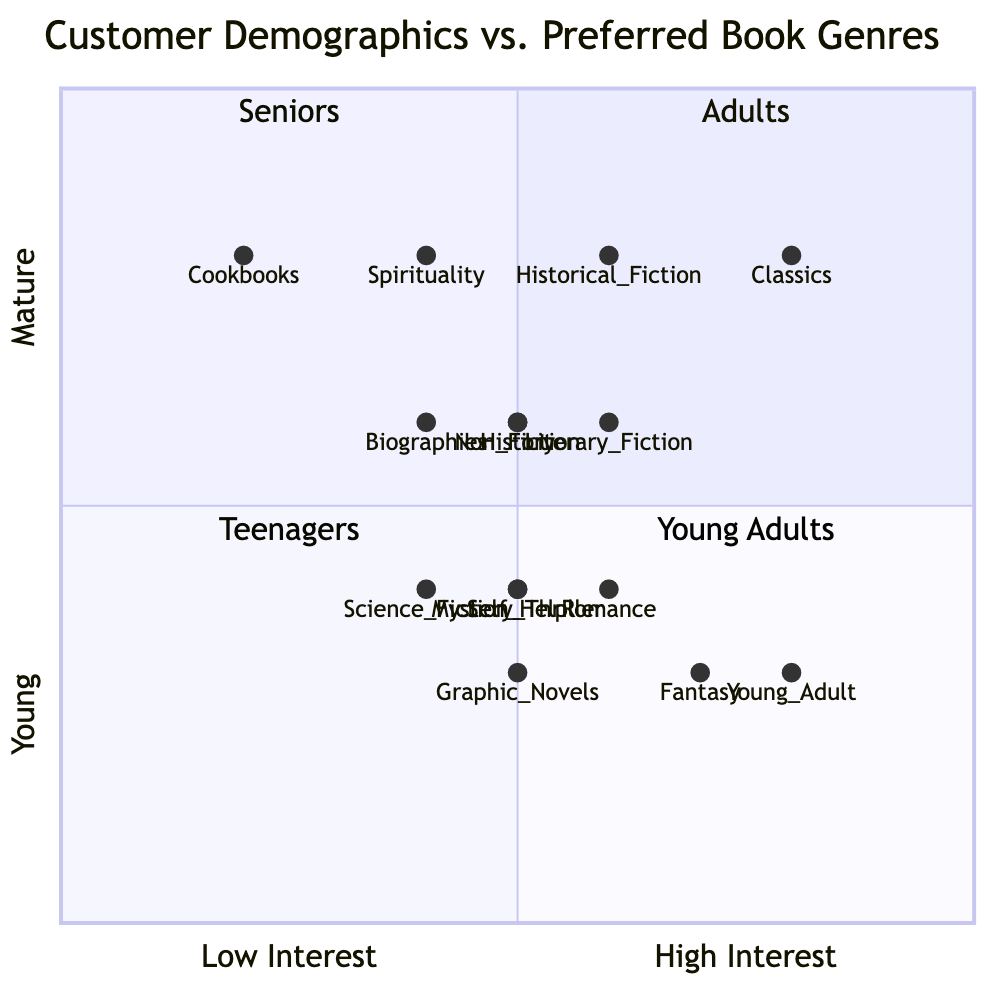What genre is most popular among teenagers? The diagram indicates that "Young Adult" with a value of 40 is the most popular genre in the Teenagers quadrant.
Answer: Young Adult Which demographic shows the highest interest in classics? According to the diagram, the "Seniors" demographic has the highest interest in "Classics," with a value of 40.
Answer: Seniors How many genres are preferred by Young Adults? The diagram lists four genres corresponding to Young Adults: Romance, Science Fiction, Mystery Thriller, and Self Help.
Answer: Four Which genre is least popular among seniors? The "Cookbooks" genre is noted to have the least popularity among Seniors, with a value of 10.
Answer: Cookbooks What is the relationship between the interest in Graphic Novels and Fantasy for Teenagers? The diagram shows that Graphic Novels have a lower interest (25) than Fantasy (35) for Teenagers, indicating that Fantasy is preferred more.
Answer: Fantasy is preferred more In which quadrant do Non-Fiction books appear? Non-Fiction is listed under the Adults quadrant, as it has been assigned a position in the Adults section of the diagram.
Answer: Adults Which two demographics have a preference for Mystery Thriller? Teenagers and Young Adults both display a preference; Teenagers have 25 and Young Adults also have 25 for Mystery Thriller.
Answer: Teenagers and Young Adults How does interest in Romance for Young Adults compare with interest in Young Adult books for Teenagers? Romance has a lower value (30) compared to Young Adult books (40), indicating that Teenagers have a greater interest in Young Adult books than Young Adults do in Romance.
Answer: Teenagers have greater interest in Young Adult books What is the average interest in fiction genres for Adults? The Adult quadrant includes Literary Fiction, Non-Fiction, Biographies, and History, averaging the total values (30+25+20+25=100) results in an average of 25.
Answer: 25 